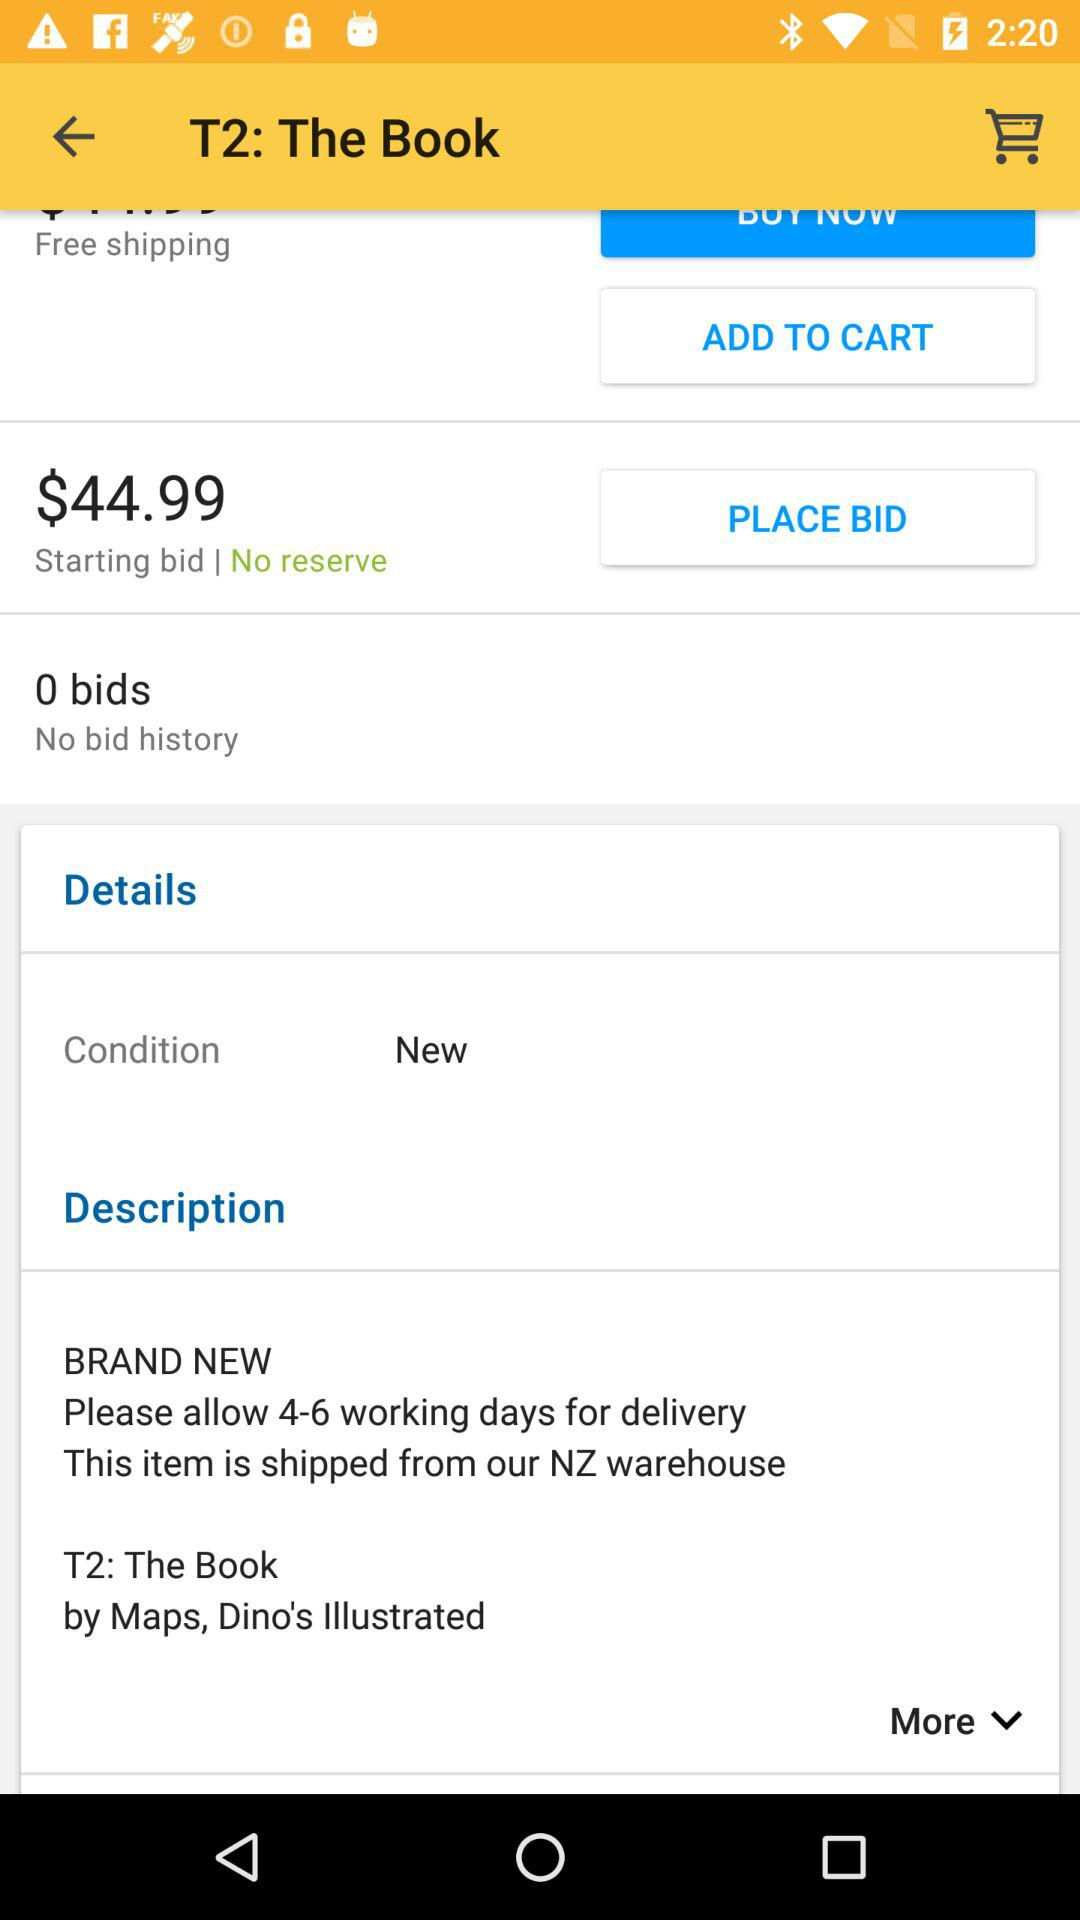How many working days are needed for delivery? For delivery, 4-6 working days are required. 